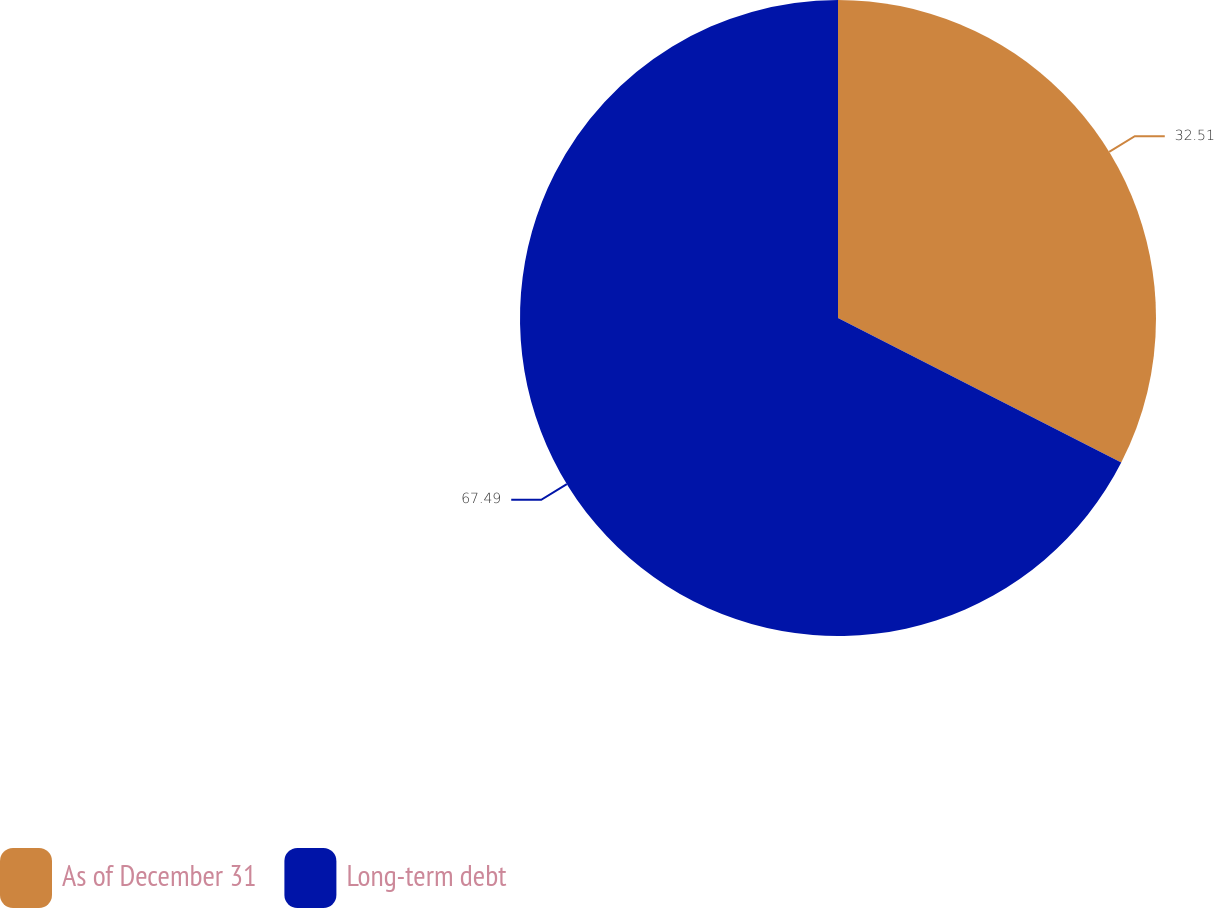Convert chart to OTSL. <chart><loc_0><loc_0><loc_500><loc_500><pie_chart><fcel>As of December 31<fcel>Long-term debt<nl><fcel>32.51%<fcel>67.49%<nl></chart> 